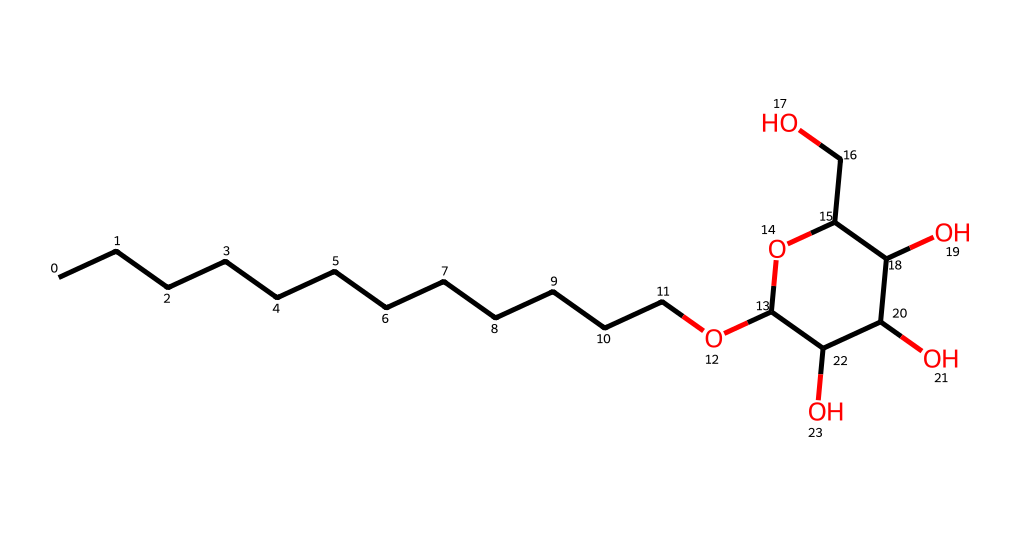How many carbon atoms are present in this molecule? The SMILES string indicates that the longest carbon chain, represented by "CCCCCCCCCCCC," contains 12 carbon atoms. Each "C" in the chain corresponds to a carbon atom.
Answer: 12 What type of surfactant is represented by this structure? The chemical structure shows that it is an alkyl polyglucoside, characterized by the alkyl group from the long carbon chain and the glucoside resulting from the sugar units in the ring.
Answer: non-ionic How many oxygen atoms are in the molecule? By analyzing the SMILES, there is one ether oxygen in the carbon chain (from "O" after "CCCCCCCCCCCC"), and four hydroxyl (–OH) groups in the sugar ring, totaling five oxygen atoms in the structure.
Answer: 5 Which component of the structure contributes to its surfactant properties? The long hydrophobic alkyl chain provides lipophilicity (oil attraction), while the hydrophilic sugar ring contributes to water solubility. Together, these properties allow for effective surfactant behavior.
Answer: alkyl chain and sugar ring What is the molecular weight of this compound based on its structure? To determine the molecular weight, the individual atomic weights of the components must be calculated: Carbon (C) contributes to 12 atoms (12 * 12.01), Oxygen (O) 5 atoms (5 * 16.00), and Hydrogen (H) accounts for 24 atoms derived from each functional group added. Calculating this gives a total approximate molecular weight.
Answer: approximately 250 g/mol What role do hydroxyl groups play in this surfactant? The hydroxyl groups (-OH) in the sugar component enhance the hydrophilicity of the molecule, promoting its solubility in water and allowing it to interact with polar substances effectively, contributing to its surfactant functionality.
Answer: enhance hydrophilicity 